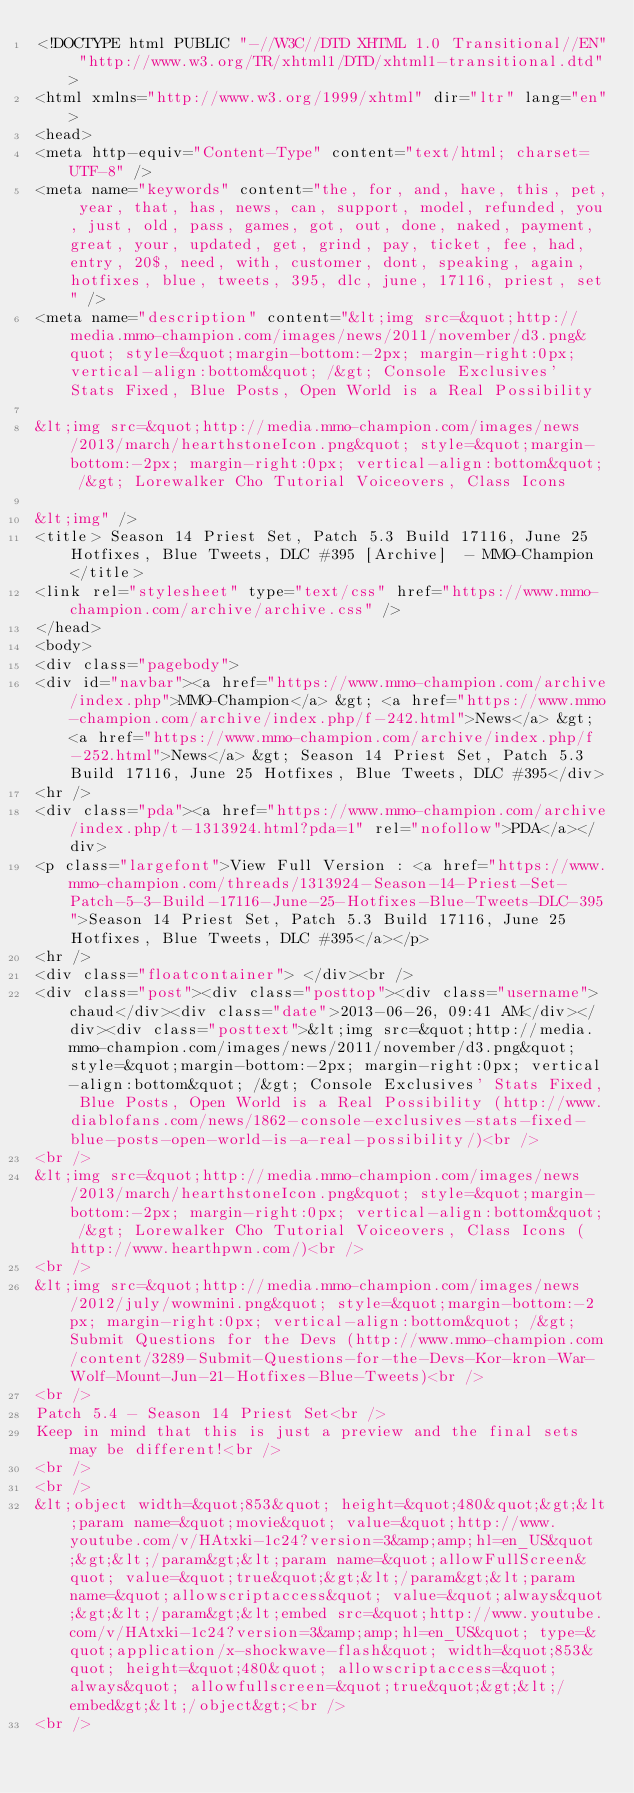<code> <loc_0><loc_0><loc_500><loc_500><_HTML_><!DOCTYPE html PUBLIC "-//W3C//DTD XHTML 1.0 Transitional//EN" "http://www.w3.org/TR/xhtml1/DTD/xhtml1-transitional.dtd">
<html xmlns="http://www.w3.org/1999/xhtml" dir="ltr" lang="en">
<head>
<meta http-equiv="Content-Type" content="text/html; charset=UTF-8" />
<meta name="keywords" content="the, for, and, have, this, pet, year, that, has, news, can, support, model, refunded, you, just, old, pass, games, got, out, done, naked, payment, great, your, updated, get, grind, pay, ticket, fee, had, entry, 20$, need, with, customer, dont, speaking, again, hotfixes, blue, tweets, 395, dlc, june, 17116, priest, set" />
<meta name="description" content="&lt;img src=&quot;http://media.mmo-champion.com/images/news/2011/november/d3.png&quot; style=&quot;margin-bottom:-2px; margin-right:0px; vertical-align:bottom&quot; /&gt; Console Exclusives' Stats Fixed, Blue Posts, Open World is a Real Possibility 
 
&lt;img src=&quot;http://media.mmo-champion.com/images/news/2013/march/hearthstoneIcon.png&quot; style=&quot;margin-bottom:-2px; margin-right:0px; vertical-align:bottom&quot; /&gt; Lorewalker Cho Tutorial Voiceovers, Class Icons 
 
&lt;img" />
<title> Season 14 Priest Set, Patch 5.3 Build 17116, June 25 Hotfixes, Blue Tweets, DLC #395 [Archive]  - MMO-Champion</title>
<link rel="stylesheet" type="text/css" href="https://www.mmo-champion.com/archive/archive.css" />
</head>
<body>
<div class="pagebody">
<div id="navbar"><a href="https://www.mmo-champion.com/archive/index.php">MMO-Champion</a> &gt; <a href="https://www.mmo-champion.com/archive/index.php/f-242.html">News</a> &gt; <a href="https://www.mmo-champion.com/archive/index.php/f-252.html">News</a> &gt; Season 14 Priest Set, Patch 5.3 Build 17116, June 25 Hotfixes, Blue Tweets, DLC #395</div>
<hr />
<div class="pda"><a href="https://www.mmo-champion.com/archive/index.php/t-1313924.html?pda=1" rel="nofollow">PDA</a></div>
<p class="largefont">View Full Version : <a href="https://www.mmo-champion.com/threads/1313924-Season-14-Priest-Set-Patch-5-3-Build-17116-June-25-Hotfixes-Blue-Tweets-DLC-395">Season 14 Priest Set, Patch 5.3 Build 17116, June 25 Hotfixes, Blue Tweets, DLC #395</a></p>
<hr />
<div class="floatcontainer"> </div><br />
<div class="post"><div class="posttop"><div class="username">chaud</div><div class="date">2013-06-26, 09:41 AM</div></div><div class="posttext">&lt;img src=&quot;http://media.mmo-champion.com/images/news/2011/november/d3.png&quot; style=&quot;margin-bottom:-2px; margin-right:0px; vertical-align:bottom&quot; /&gt; Console Exclusives' Stats Fixed, Blue Posts, Open World is a Real Possibility (http://www.diablofans.com/news/1862-console-exclusives-stats-fixed-blue-posts-open-world-is-a-real-possibility/)<br />
<br />
&lt;img src=&quot;http://media.mmo-champion.com/images/news/2013/march/hearthstoneIcon.png&quot; style=&quot;margin-bottom:-2px; margin-right:0px; vertical-align:bottom&quot; /&gt; Lorewalker Cho Tutorial Voiceovers, Class Icons (http://www.hearthpwn.com/)<br />
<br />
&lt;img src=&quot;http://media.mmo-champion.com/images/news/2012/july/wowmini.png&quot; style=&quot;margin-bottom:-2px; margin-right:0px; vertical-align:bottom&quot; /&gt; Submit Questions for the Devs (http://www.mmo-champion.com/content/3289-Submit-Questions-for-the-Devs-Kor-kron-War-Wolf-Mount-Jun-21-Hotfixes-Blue-Tweets)<br />
<br />
Patch 5.4 - Season 14 Priest Set<br />
Keep in mind that this is just a preview and the final sets may be different!<br />
<br />
<br />
&lt;object width=&quot;853&quot; height=&quot;480&quot;&gt;&lt;param name=&quot;movie&quot; value=&quot;http://www.youtube.com/v/HAtxki-1c24?version=3&amp;amp;hl=en_US&quot;&gt;&lt;/param&gt;&lt;param name=&quot;allowFullScreen&quot; value=&quot;true&quot;&gt;&lt;/param&gt;&lt;param name=&quot;allowscriptaccess&quot; value=&quot;always&quot;&gt;&lt;/param&gt;&lt;embed src=&quot;http://www.youtube.com/v/HAtxki-1c24?version=3&amp;amp;hl=en_US&quot; type=&quot;application/x-shockwave-flash&quot; width=&quot;853&quot; height=&quot;480&quot; allowscriptaccess=&quot;always&quot; allowfullscreen=&quot;true&quot;&gt;&lt;/embed&gt;&lt;/object&gt;<br />
<br /></code> 